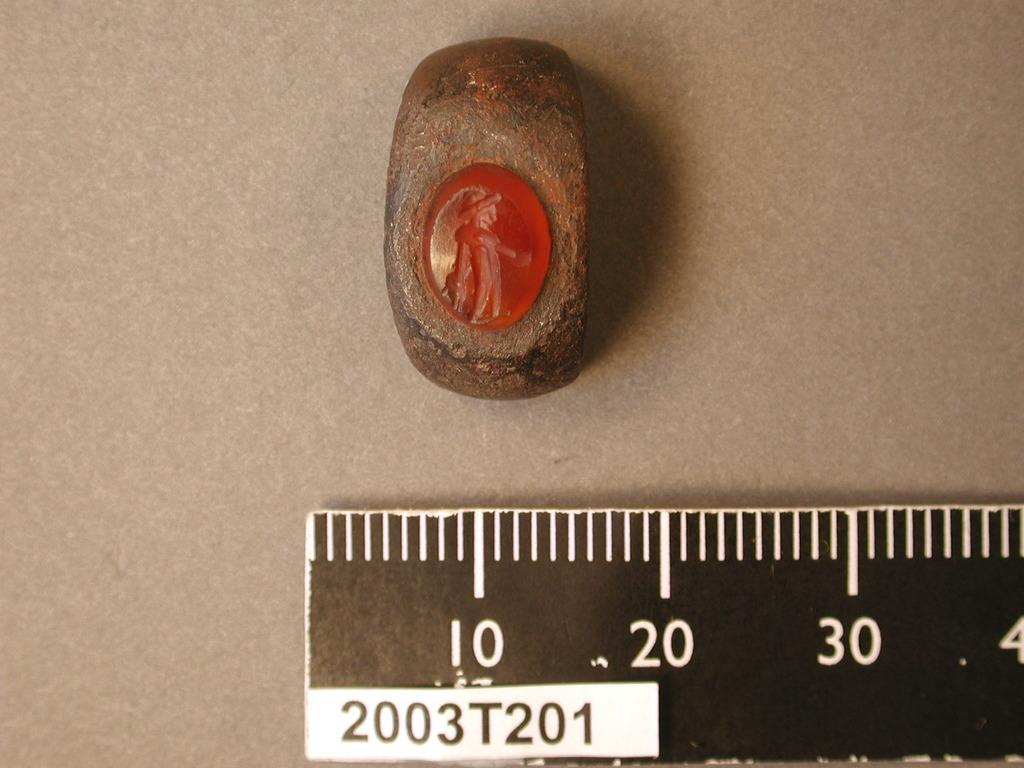<image>
Give a short and clear explanation of the subsequent image. A rock with a red stone pressed into it above a ruler that starts at 10 and is marked 2003T201 